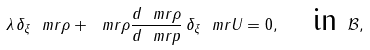<formula> <loc_0><loc_0><loc_500><loc_500>\lambda \, \delta _ { \xi } \ m r { \rho } + \ m r { \rho } \frac { d \ m r { \rho } } { d \ m r { p } } \, \delta _ { \xi } \ m r { U } = 0 , \quad \text {in } \mathcal { B } ,</formula> 